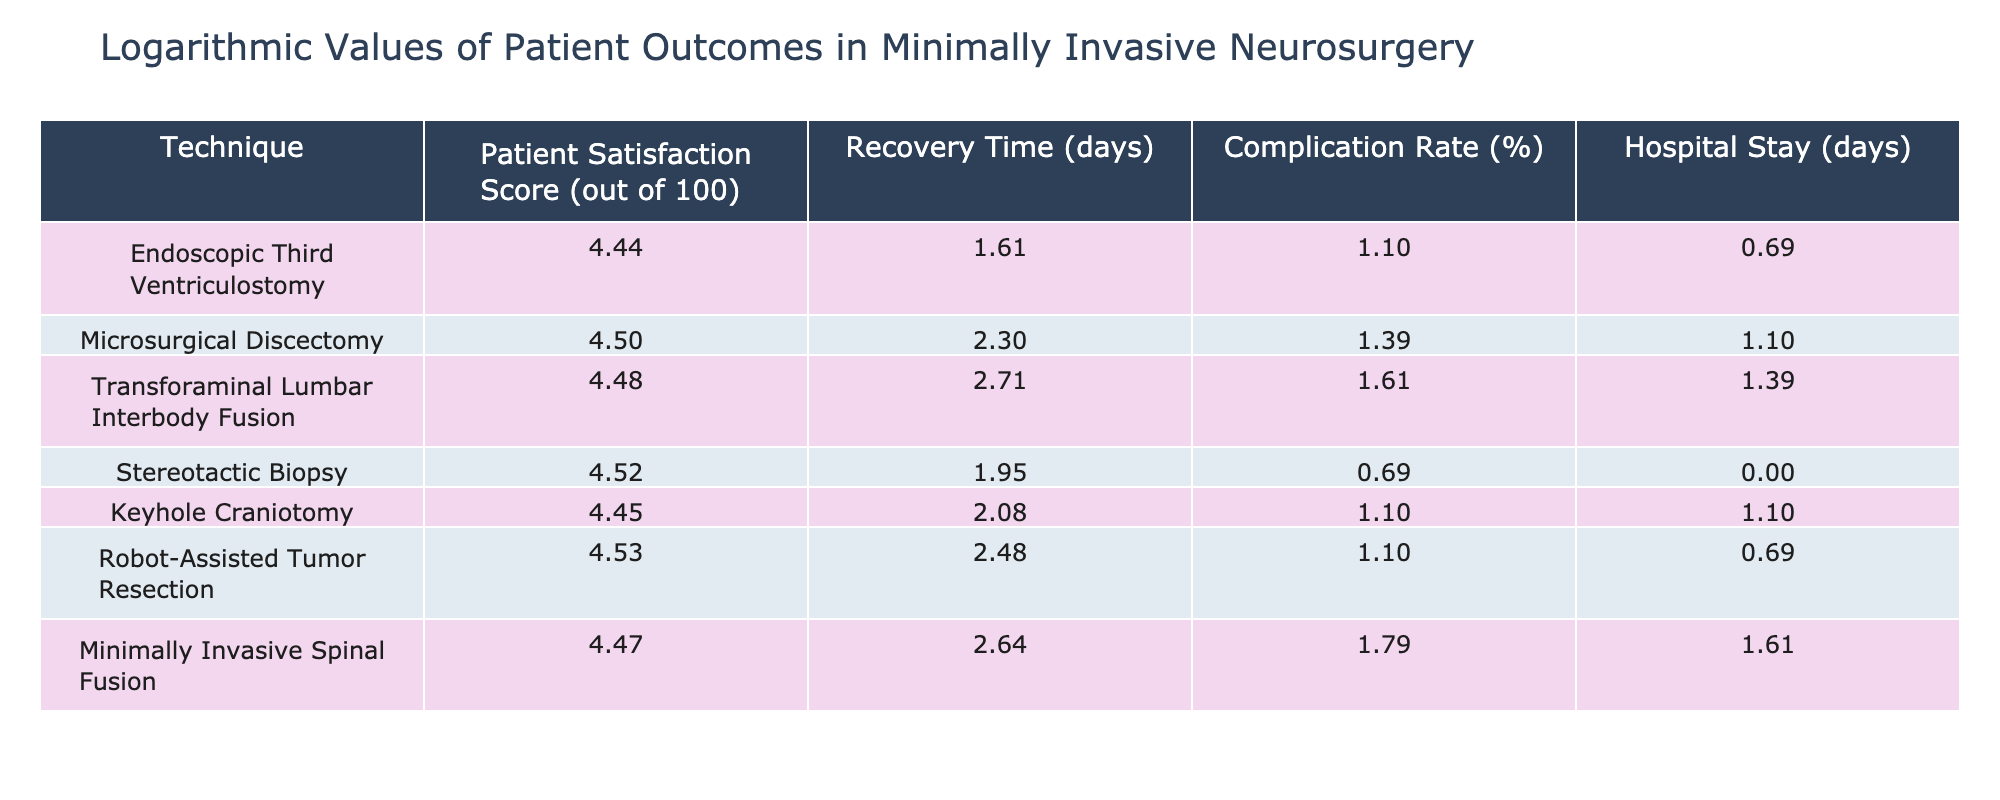What is the patient satisfaction score for Robot-Assisted Tumor Resection? The table lists the patient satisfaction score for each technique, and for Robot-Assisted Tumor Resection, it is explicitly shown as 93.
Answer: 93 What is the complication rate for Minimally Invasive Spinal Fusion? The complication rate is directly provided in the table for Minimally Invasive Spinal Fusion, which is 6%.
Answer: 6% What is the average recovery time for the techniques listed? The recovery times are 5, 10, 15, 7, 8, 12, and 14 days. Adding these gives 71, and dividing by 7 (the number of techniques) gives an average of 10.14 days.
Answer: 10.14 Is the complication rate higher for Microsurgical Discectomy compared to Stereotactic Biopsy? The complication rate for Microsurgical Discectomy is 4%, and for Stereotactic Biopsy, it is 2%. Since 4% is greater than 2%, the answer is yes.
Answer: Yes Which technique has the shortest hospital stay, and what is the duration? Examining the hospital stay column, the shortest duration is 1 day for Stereotactic Biopsy. The technique with this duration is Stereotactic Biopsy.
Answer: Stereotactic Biopsy, 1 day What is the total hospital stay for all techniques combined? The hospital stays are 2, 3, 4, 1, 3, 2, and 5 days. Adding them gives a total of 20 days (2 + 3 + 4 + 1 + 3 + 2 + 5 = 20).
Answer: 20 Which technique has the highest patient satisfaction score and what is that score? By examining the patient satisfaction scores listed, Robot-Assisted Tumor Resection has the highest score at 93.
Answer: Robot-Assisted Tumor Resection, 93 Is the hospital stay for Keyhole Craniotomy shorter than that of Transforaminal Lumbar Interbody Fusion? Keyhole Craniotomy has a hospital stay of 3 days, while Transforaminal Lumbar Interbody Fusion has a hospital stay of 4 days. Since 3 is less than 4, the answer is yes.
Answer: Yes What is the difference in the complication rates between Endoscopic Third Ventriculostomy and Minimally Invasive Spinal Fusion? The complication rate for Endoscopic Third Ventriculostomy is 3%, and for Minimally Invasive Spinal Fusion is 6%. The difference is 6 - 3 = 3%.
Answer: 3% 